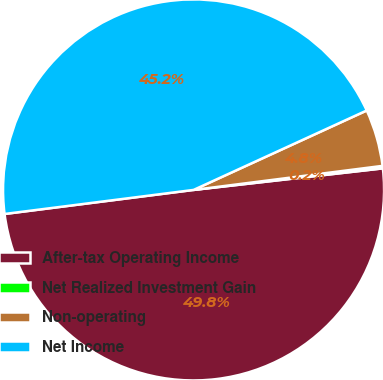Convert chart to OTSL. <chart><loc_0><loc_0><loc_500><loc_500><pie_chart><fcel>After-tax Operating Income<fcel>Net Realized Investment Gain<fcel>Non-operating<fcel>Net Income<nl><fcel>49.79%<fcel>0.21%<fcel>4.83%<fcel>45.17%<nl></chart> 